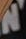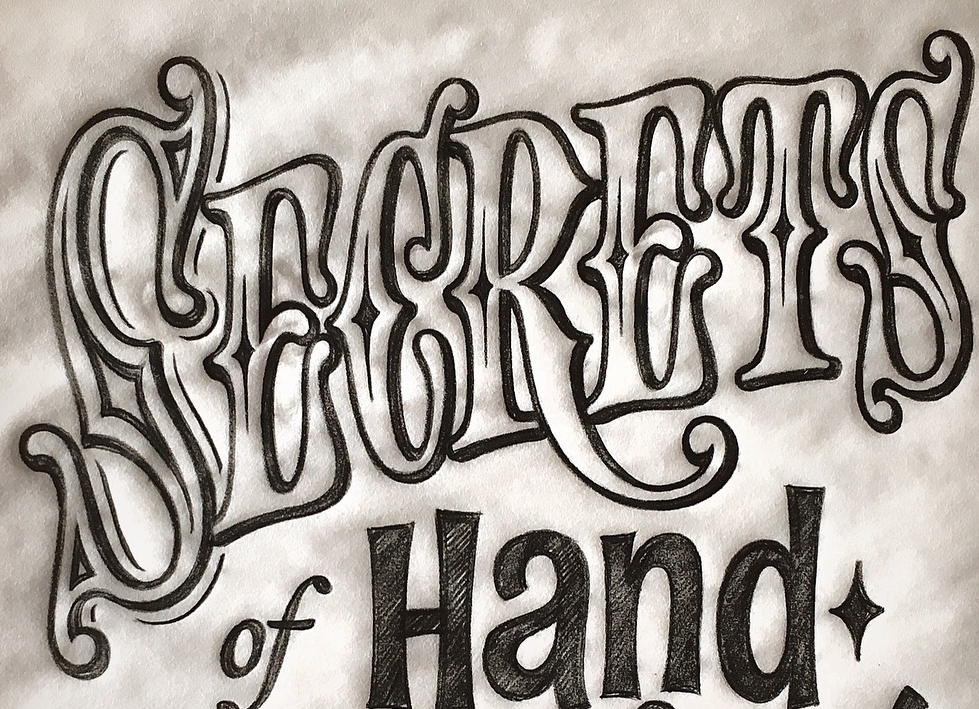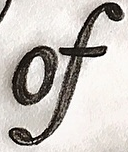What words can you see in these images in sequence, separated by a semicolon? N; SECRETS; of 